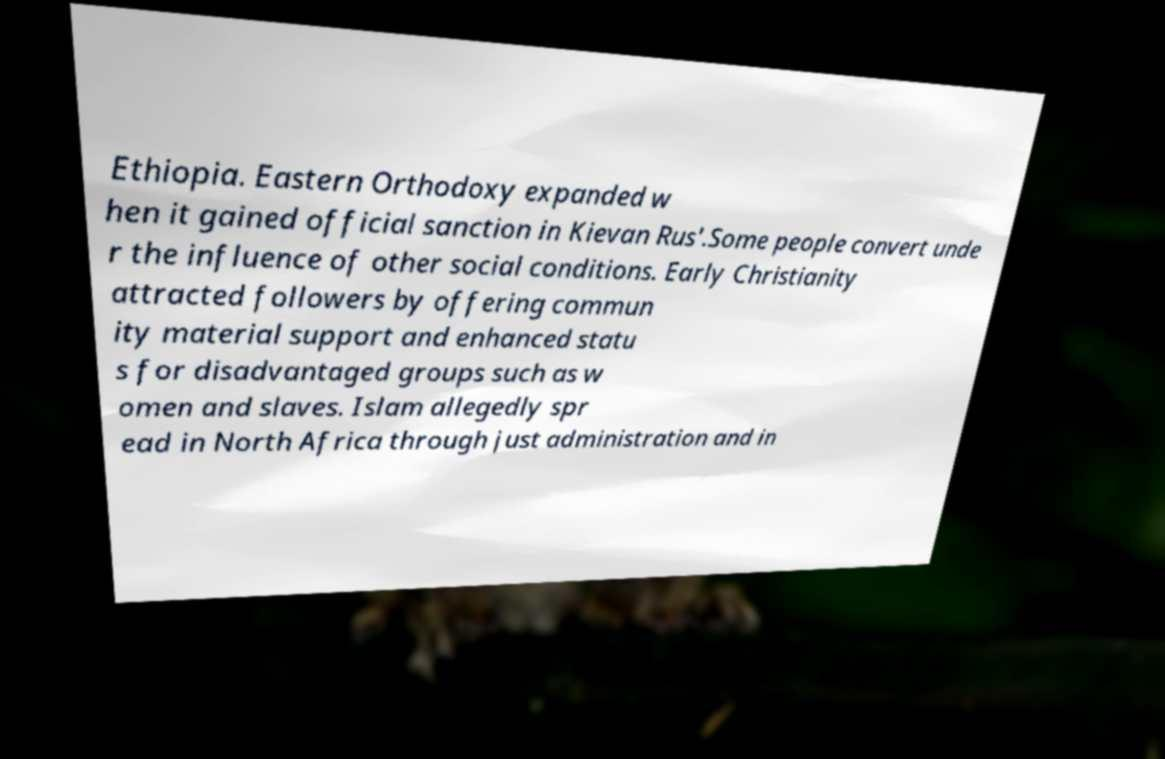Please read and relay the text visible in this image. What does it say? Ethiopia. Eastern Orthodoxy expanded w hen it gained official sanction in Kievan Rus'.Some people convert unde r the influence of other social conditions. Early Christianity attracted followers by offering commun ity material support and enhanced statu s for disadvantaged groups such as w omen and slaves. Islam allegedly spr ead in North Africa through just administration and in 